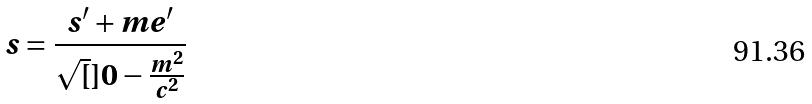Convert formula to latex. <formula><loc_0><loc_0><loc_500><loc_500>s = \frac { s ^ { \prime } + m e ^ { \prime } } { \sqrt { [ } ] { 0 - \frac { m ^ { 2 } } { c ^ { 2 } } } }</formula> 